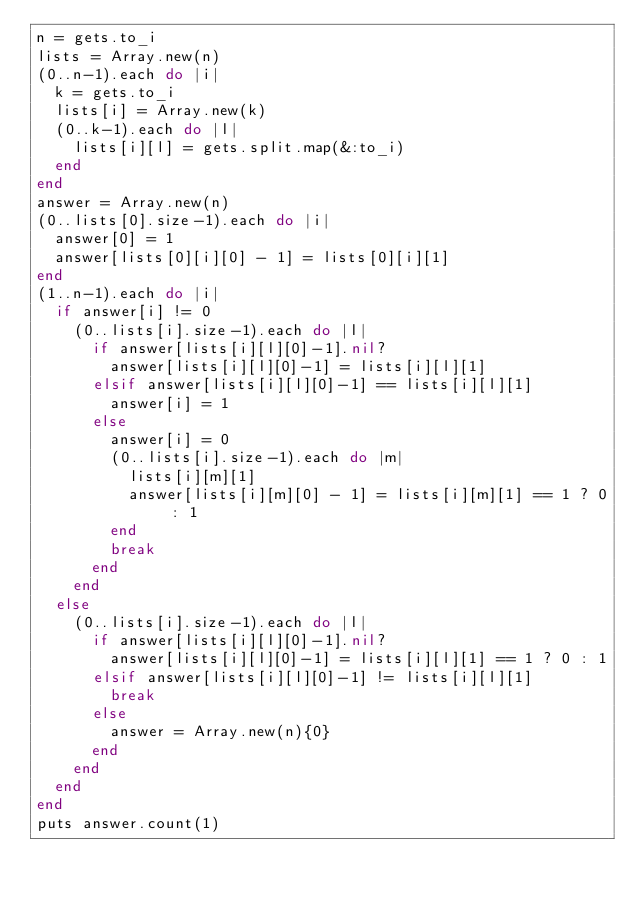Convert code to text. <code><loc_0><loc_0><loc_500><loc_500><_Ruby_>n = gets.to_i
lists = Array.new(n)
(0..n-1).each do |i|
  k = gets.to_i
  lists[i] = Array.new(k)
  (0..k-1).each do |l|
    lists[i][l] = gets.split.map(&:to_i)
  end
end
answer = Array.new(n)
(0..lists[0].size-1).each do |i|
  answer[0] = 1
  answer[lists[0][i][0] - 1] = lists[0][i][1]
end
(1..n-1).each do |i|
  if answer[i] != 0
    (0..lists[i].size-1).each do |l|
      if answer[lists[i][l][0]-1].nil?
        answer[lists[i][l][0]-1] = lists[i][l][1]
      elsif answer[lists[i][l][0]-1] == lists[i][l][1]
        answer[i] = 1
      else
        answer[i] = 0
        (0..lists[i].size-1).each do |m|
          lists[i][m][1]
          answer[lists[i][m][0] - 1] = lists[i][m][1] == 1 ? 0 : 1
        end
        break
      end
    end
  else
    (0..lists[i].size-1).each do |l|
      if answer[lists[i][l][0]-1].nil?
        answer[lists[i][l][0]-1] = lists[i][l][1] == 1 ? 0 : 1
      elsif answer[lists[i][l][0]-1] != lists[i][l][1]
        break
      else
        answer = Array.new(n){0}
      end
    end
  end
end
puts answer.count(1)
</code> 